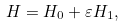Convert formula to latex. <formula><loc_0><loc_0><loc_500><loc_500>H = H _ { 0 } + \varepsilon H _ { 1 } ,</formula> 